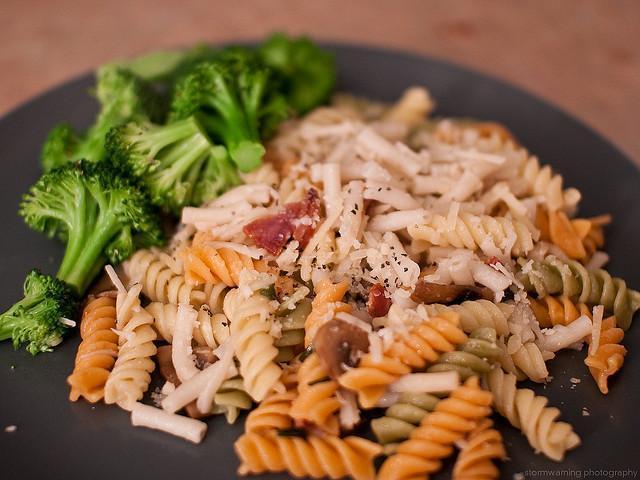How many broccolis are in the picture?
Give a very brief answer. 2. How many cats are there?
Give a very brief answer. 0. 